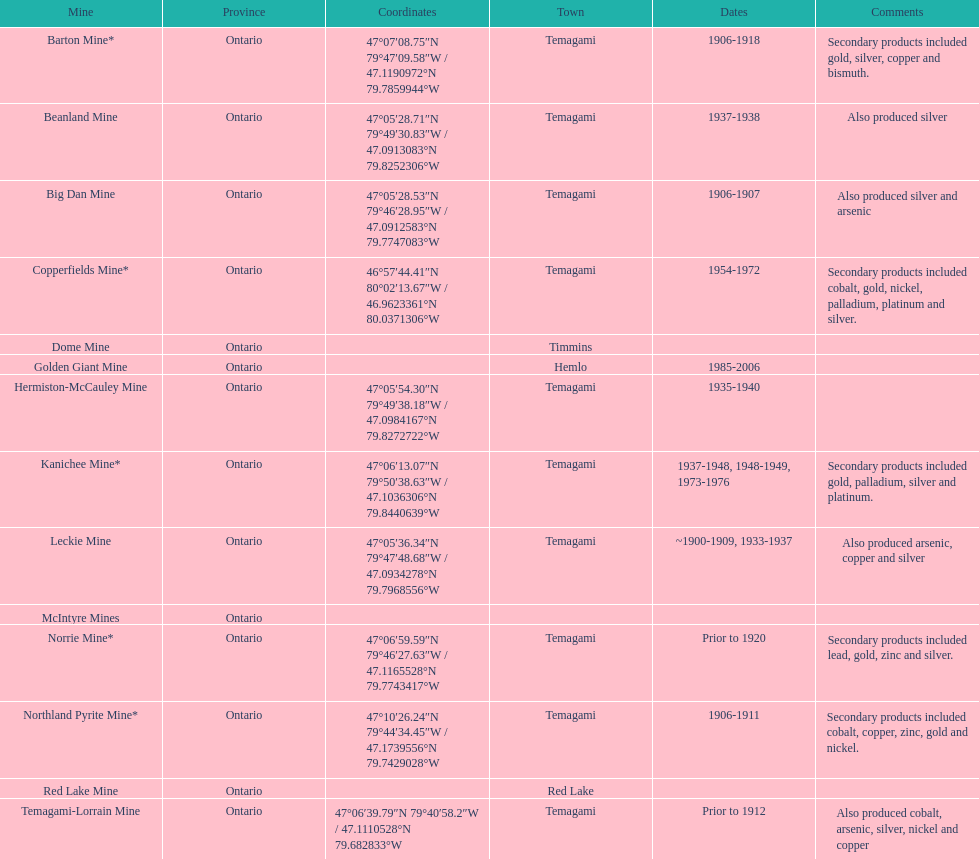Between golden giant and beanland mine, which one was open for a longer duration? Golden Giant Mine. Parse the table in full. {'header': ['Mine', 'Province', 'Coordinates', 'Town', 'Dates', 'Comments'], 'rows': [['Barton Mine*', 'Ontario', '47°07′08.75″N 79°47′09.58″W\ufeff / \ufeff47.1190972°N 79.7859944°W', 'Temagami', '1906-1918', 'Secondary products included gold, silver, copper and bismuth.'], ['Beanland Mine', 'Ontario', '47°05′28.71″N 79°49′30.83″W\ufeff / \ufeff47.0913083°N 79.8252306°W', 'Temagami', '1937-1938', 'Also produced silver'], ['Big Dan Mine', 'Ontario', '47°05′28.53″N 79°46′28.95″W\ufeff / \ufeff47.0912583°N 79.7747083°W', 'Temagami', '1906-1907', 'Also produced silver and arsenic'], ['Copperfields Mine*', 'Ontario', '46°57′44.41″N 80°02′13.67″W\ufeff / \ufeff46.9623361°N 80.0371306°W', 'Temagami', '1954-1972', 'Secondary products included cobalt, gold, nickel, palladium, platinum and silver.'], ['Dome Mine', 'Ontario', '', 'Timmins', '', ''], ['Golden Giant Mine', 'Ontario', '', 'Hemlo', '1985-2006', ''], ['Hermiston-McCauley Mine', 'Ontario', '47°05′54.30″N 79°49′38.18″W\ufeff / \ufeff47.0984167°N 79.8272722°W', 'Temagami', '1935-1940', ''], ['Kanichee Mine*', 'Ontario', '47°06′13.07″N 79°50′38.63″W\ufeff / \ufeff47.1036306°N 79.8440639°W', 'Temagami', '1937-1948, 1948-1949, 1973-1976', 'Secondary products included gold, palladium, silver and platinum.'], ['Leckie Mine', 'Ontario', '47°05′36.34″N 79°47′48.68″W\ufeff / \ufeff47.0934278°N 79.7968556°W', 'Temagami', '~1900-1909, 1933-1937', 'Also produced arsenic, copper and silver'], ['McIntyre Mines', 'Ontario', '', '', '', ''], ['Norrie Mine*', 'Ontario', '47°06′59.59″N 79°46′27.63″W\ufeff / \ufeff47.1165528°N 79.7743417°W', 'Temagami', 'Prior to 1920', 'Secondary products included lead, gold, zinc and silver.'], ['Northland Pyrite Mine*', 'Ontario', '47°10′26.24″N 79°44′34.45″W\ufeff / \ufeff47.1739556°N 79.7429028°W', 'Temagami', '1906-1911', 'Secondary products included cobalt, copper, zinc, gold and nickel.'], ['Red Lake Mine', 'Ontario', '', 'Red Lake', '', ''], ['Temagami-Lorrain Mine', 'Ontario', '47°06′39.79″N 79°40′58.2″W\ufeff / \ufeff47.1110528°N 79.682833°W', 'Temagami', 'Prior to 1912', 'Also produced cobalt, arsenic, silver, nickel and copper']]} 